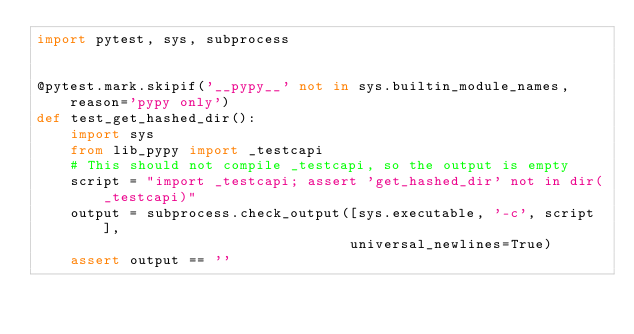<code> <loc_0><loc_0><loc_500><loc_500><_Python_>import pytest, sys, subprocess


@pytest.mark.skipif('__pypy__' not in sys.builtin_module_names, reason='pypy only')
def test_get_hashed_dir():
    import sys
    from lib_pypy import _testcapi
    # This should not compile _testcapi, so the output is empty
    script = "import _testcapi; assert 'get_hashed_dir' not in dir(_testcapi)"
    output = subprocess.check_output([sys.executable, '-c', script],
                                     universal_newlines=True)
    assert output == ''
            
</code> 